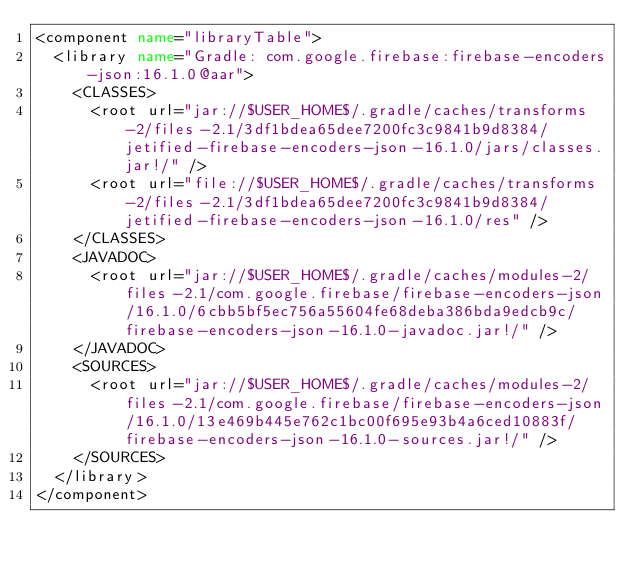<code> <loc_0><loc_0><loc_500><loc_500><_XML_><component name="libraryTable">
  <library name="Gradle: com.google.firebase:firebase-encoders-json:16.1.0@aar">
    <CLASSES>
      <root url="jar://$USER_HOME$/.gradle/caches/transforms-2/files-2.1/3df1bdea65dee7200fc3c9841b9d8384/jetified-firebase-encoders-json-16.1.0/jars/classes.jar!/" />
      <root url="file://$USER_HOME$/.gradle/caches/transforms-2/files-2.1/3df1bdea65dee7200fc3c9841b9d8384/jetified-firebase-encoders-json-16.1.0/res" />
    </CLASSES>
    <JAVADOC>
      <root url="jar://$USER_HOME$/.gradle/caches/modules-2/files-2.1/com.google.firebase/firebase-encoders-json/16.1.0/6cbb5bf5ec756a55604fe68deba386bda9edcb9c/firebase-encoders-json-16.1.0-javadoc.jar!/" />
    </JAVADOC>
    <SOURCES>
      <root url="jar://$USER_HOME$/.gradle/caches/modules-2/files-2.1/com.google.firebase/firebase-encoders-json/16.1.0/13e469b445e762c1bc00f695e93b4a6ced10883f/firebase-encoders-json-16.1.0-sources.jar!/" />
    </SOURCES>
  </library>
</component></code> 